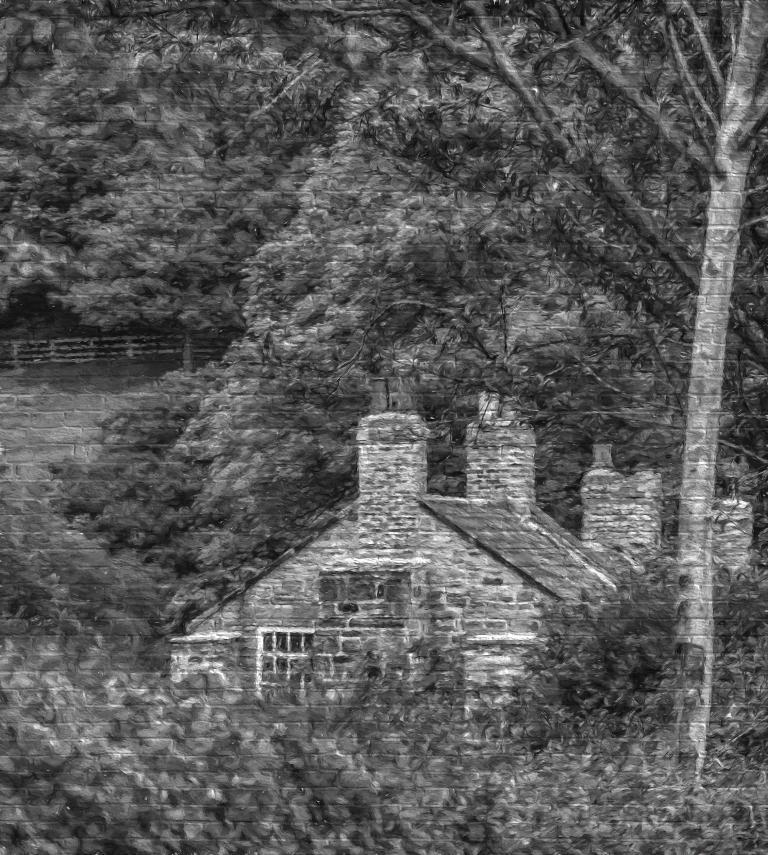Could you give a brief overview of what you see in this image? In this image we can see the painting on the wall, in the painting there are trees, and the house. 